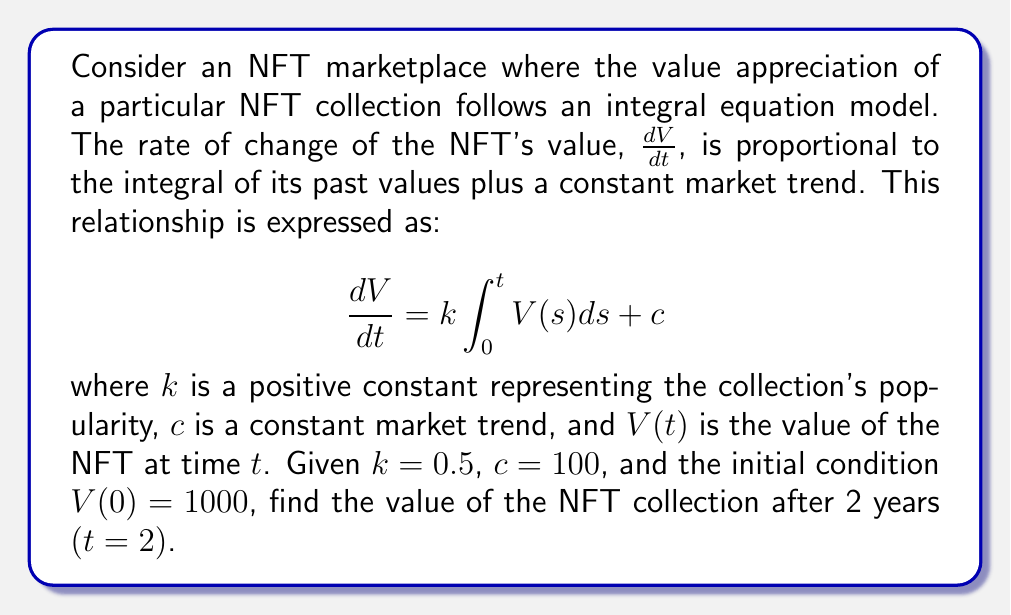Could you help me with this problem? To solve this integral equation, we'll follow these steps:

1) First, we differentiate both sides of the equation with respect to $t$:

   $$\frac{d^2V}{dt^2} = k\frac{d}{dt}\int_0^t V(s)ds + 0$$

2) Using the Fundamental Theorem of Calculus:

   $$\frac{d^2V}{dt^2} = kV(t)$$

3) This is a second-order linear differential equation. The general solution is:

   $$V(t) = A e^{\sqrt{k}t} + B e^{-\sqrt{k}t} + \frac{c}{k}$$

   where $A$ and $B$ are constants to be determined.

4) To find $A$ and $B$, we use the initial condition and the original integral equation:

   At $t=0$: $V(0) = A + B + \frac{c}{k} = 1000$

   Substituting the general solution into the original equation:

   $$\sqrt{k}(A e^{\sqrt{k}t} - B e^{-\sqrt{k}t}) = k(\frac{A}{\sqrt{k}}e^{\sqrt{k}t} - \frac{B}{\sqrt{k}}e^{-\sqrt{k}t}) + c$$

5) This equality must hold for all $t$, so:

   $A = \frac{c}{2k} = 100$ and $B = 1000 - A - \frac{c}{k} = 700$

6) Therefore, the solution is:

   $$V(t) = 100 e^{\frac{\sqrt{2}}{2}t} + 700 e^{-\frac{\sqrt{2}}{2}t} + 200$$

7) At $t=2$:

   $$V(2) = 100 e^{\sqrt{2}} + 700 e^{-\sqrt{2}} + 200 \approx 1544.62$$
Answer: $1544.62 